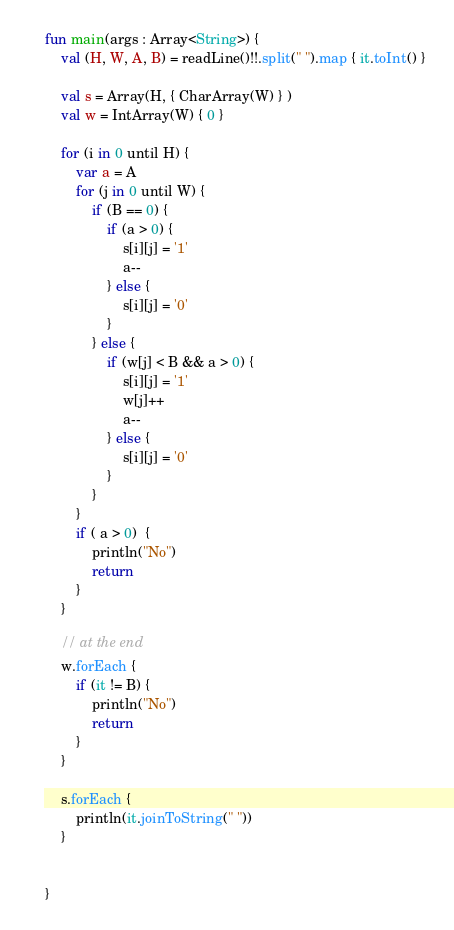<code> <loc_0><loc_0><loc_500><loc_500><_Kotlin_>fun main(args : Array<String>) {
    val (H, W, A, B) = readLine()!!.split(" ").map { it.toInt() }

    val s = Array(H, { CharArray(W) } )
    val w = IntArray(W) { 0 }

    for (i in 0 until H) {
        var a = A
        for (j in 0 until W) {
            if (B == 0) {
                if (a > 0) {
                    s[i][j] = '1'
                    a--
                } else {
                    s[i][j] = '0'
                }
            } else {
                if (w[j] < B && a > 0) {
                    s[i][j] = '1'
                    w[j]++
                    a--
                } else {
                    s[i][j] = '0'
                }
            }
        }
        if ( a > 0)  {
            println("No")
            return
        }
    }

    // at the end
    w.forEach {
        if (it != B) {
            println("No")
            return
        }
    }

    s.forEach {
        println(it.joinToString(" "))
    }


}</code> 